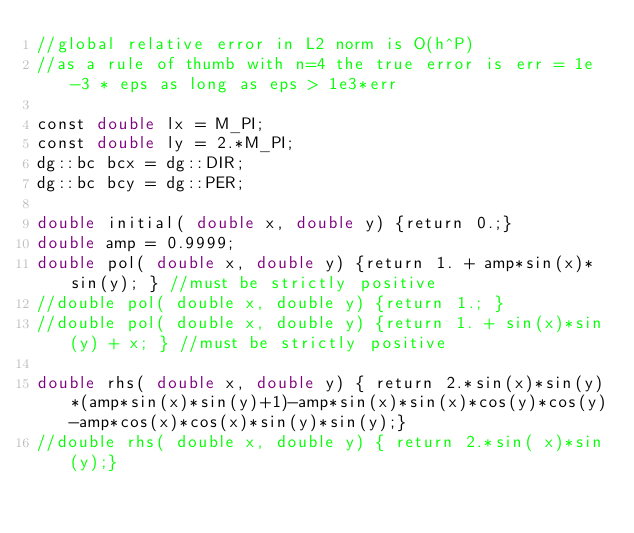Convert code to text. <code><loc_0><loc_0><loc_500><loc_500><_Cuda_>//global relative error in L2 norm is O(h^P)
//as a rule of thumb with n=4 the true error is err = 1e-3 * eps as long as eps > 1e3*err

const double lx = M_PI;
const double ly = 2.*M_PI;
dg::bc bcx = dg::DIR;
dg::bc bcy = dg::PER;

double initial( double x, double y) {return 0.;}
double amp = 0.9999;
double pol( double x, double y) {return 1. + amp*sin(x)*sin(y); } //must be strictly positive
//double pol( double x, double y) {return 1.; }
//double pol( double x, double y) {return 1. + sin(x)*sin(y) + x; } //must be strictly positive

double rhs( double x, double y) { return 2.*sin(x)*sin(y)*(amp*sin(x)*sin(y)+1)-amp*sin(x)*sin(x)*cos(y)*cos(y)-amp*cos(x)*cos(x)*sin(y)*sin(y);}
//double rhs( double x, double y) { return 2.*sin( x)*sin(y);}</code> 